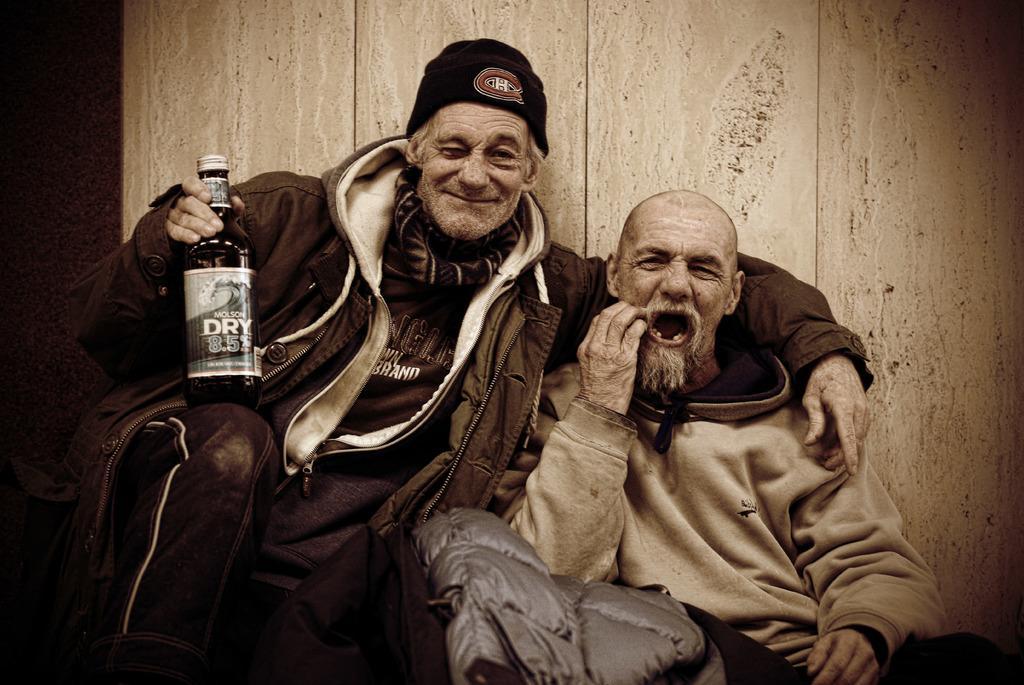Describe this image in one or two sentences. In the foreground of this image, there are two old men sitting and a man wearing coat and holding a bottle and a hand over the other person. In the background, there is a wooden wall. On the bottom, there is a coat. 